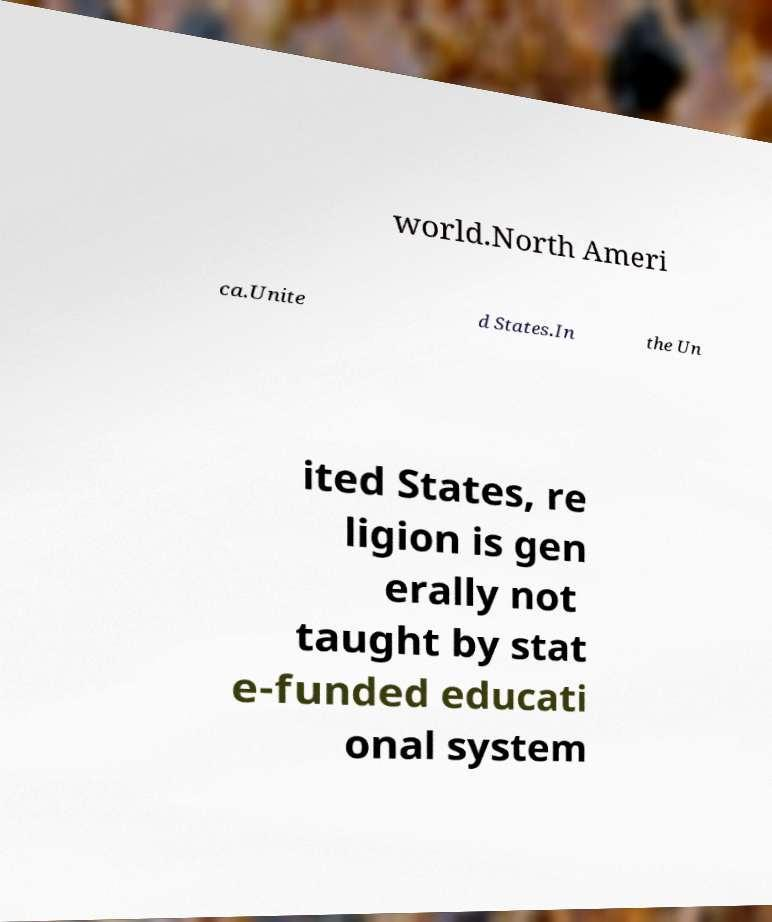There's text embedded in this image that I need extracted. Can you transcribe it verbatim? world.North Ameri ca.Unite d States.In the Un ited States, re ligion is gen erally not taught by stat e-funded educati onal system 